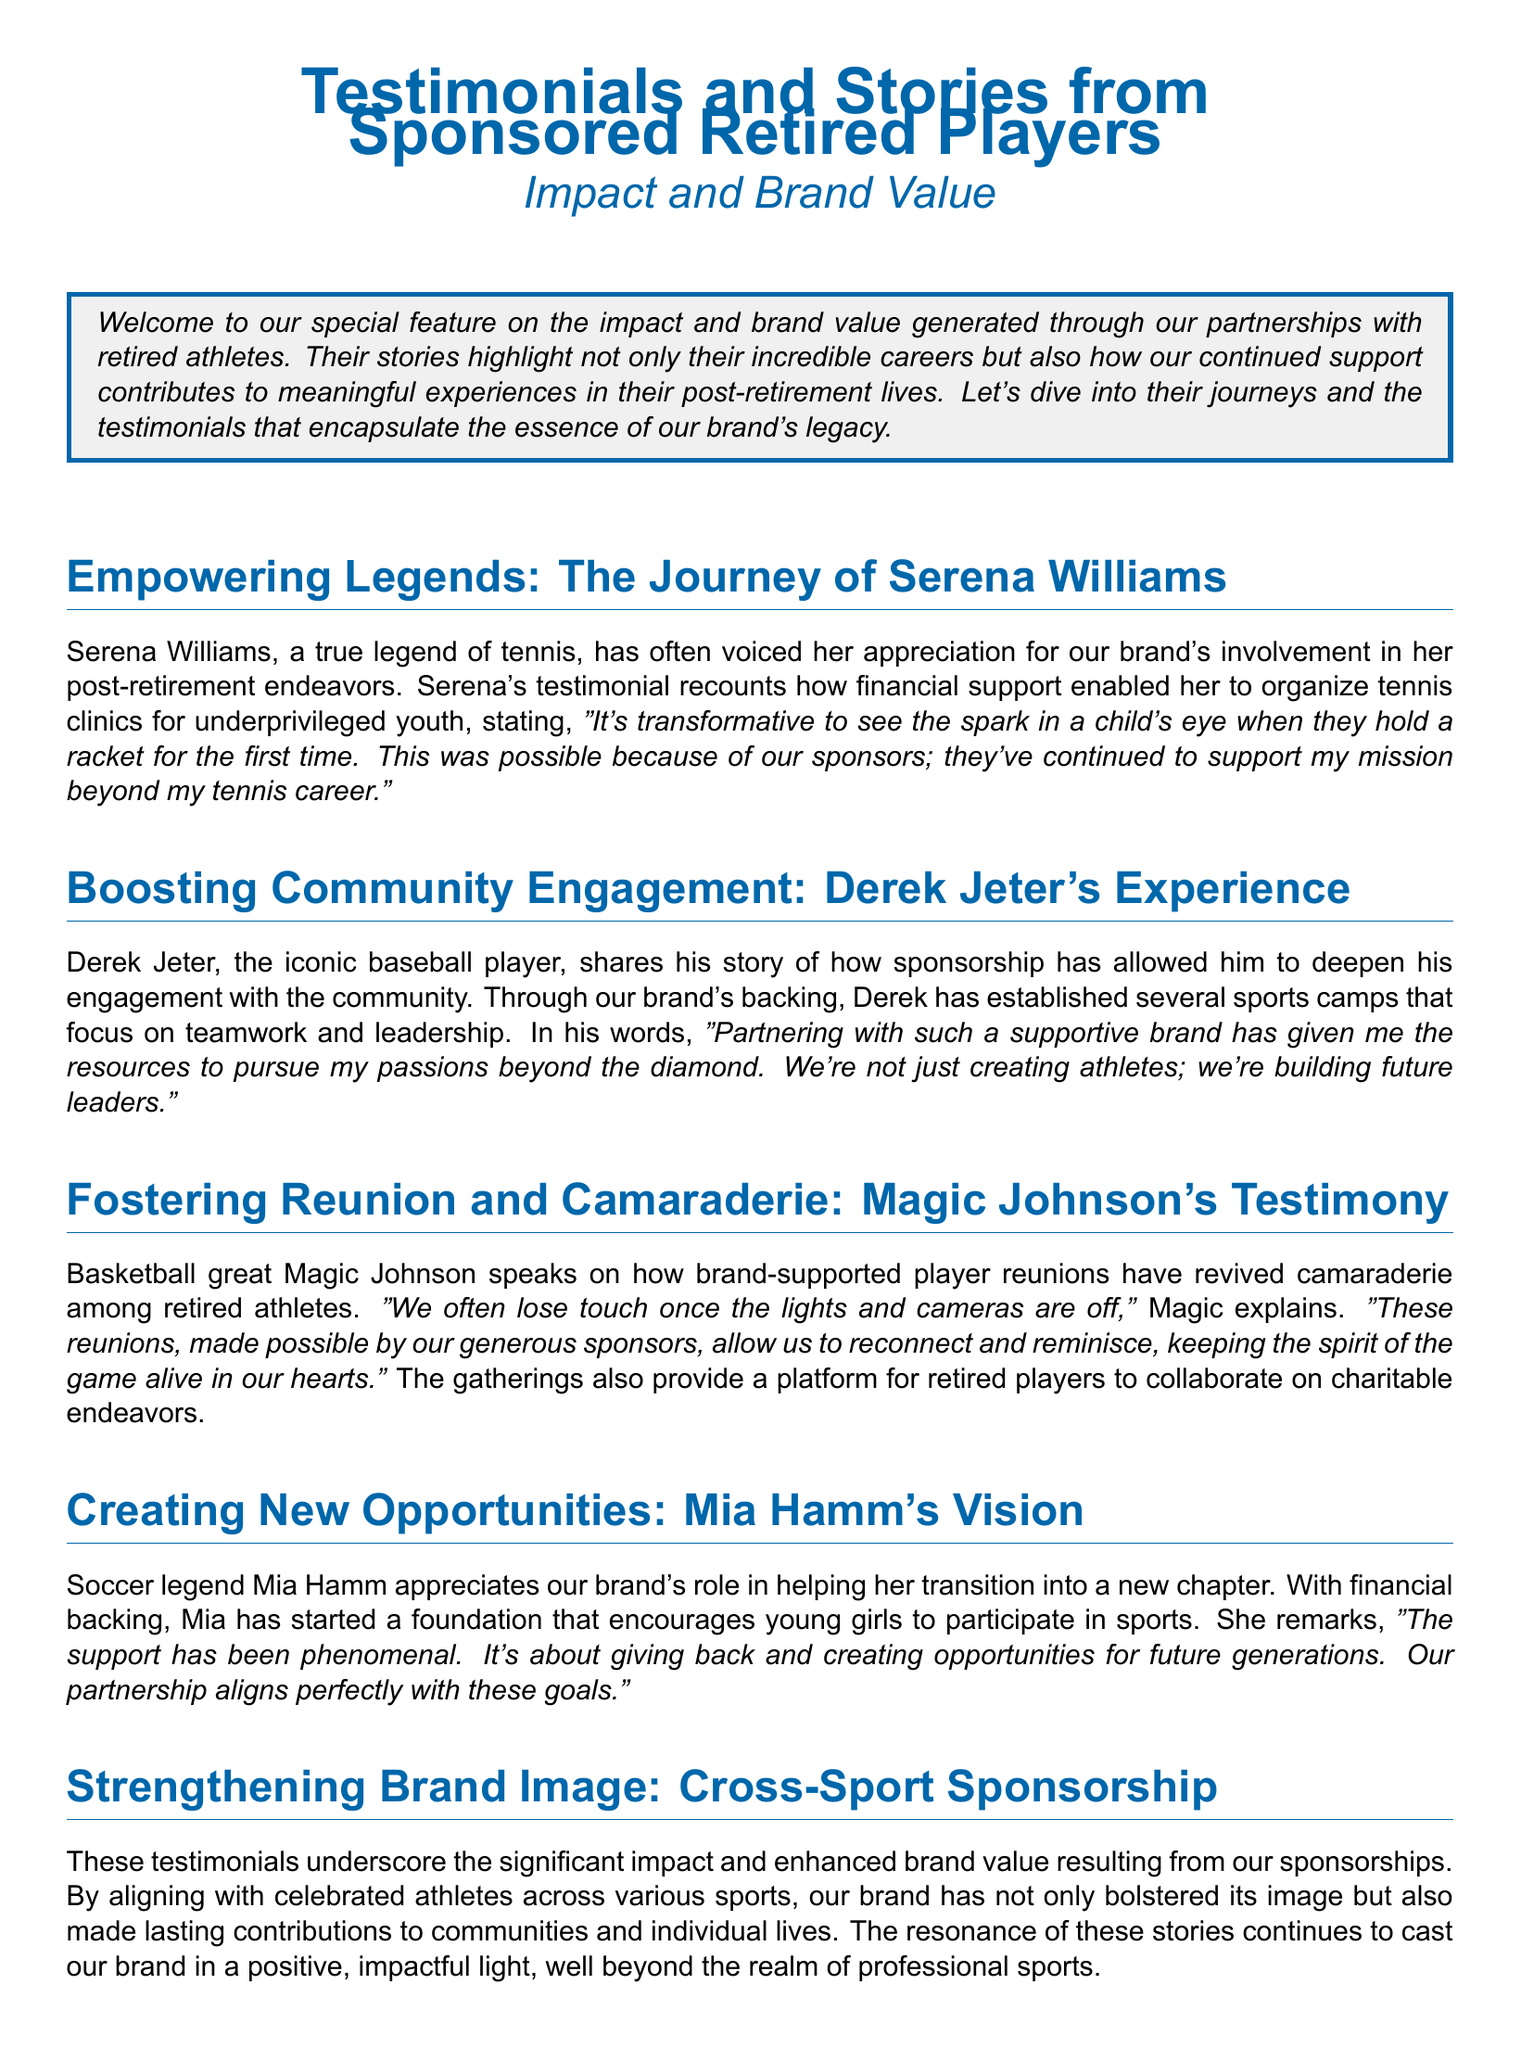what is the main theme of the document? The document focuses on the impact and brand value generated through partnerships with retired athletes, highlighting their testimonials and stories.
Answer: impact and brand value who is the tennis legend mentioned in the document? The document specifically mentions Serena Williams as a tennis legend.
Answer: Serena Williams what type of initiatives did Derek Jeter establish with sponsorship support? The initiatives he established focus on teamwork and leadership through sports camps.
Answer: sports camps which retired athlete started a foundation for young girls? The document states that Mia Hamm started a foundation encouraging young girls to participate in sports.
Answer: Mia Hamm what aspect of retired players' lives does Magic Johnson emphasize in his testimony? Magic Johnson emphasizes the camaraderie that reunions foster among retired players.
Answer: camaraderie how does Mia Hamm describe the support she received? Mia Hamm describes the support she received as phenomenal.
Answer: phenomenal what positive outcomes are attributed to the brand's sponsorships? The document attributes enhanced brand value and contributions to communities and individual lives to the sponsorships.
Answer: enhanced brand value what do the testimonials serve as a testament to? The testimonials serve as a testament to the brand's commitment to supporting athletes.
Answer: commitment to supporting athletes how does the document portray the relationship between the brand and retired athletes? The document portrays the relationship as mutually beneficial, supporting their endeavors while enhancing the brand's image.
Answer: mutually beneficial 